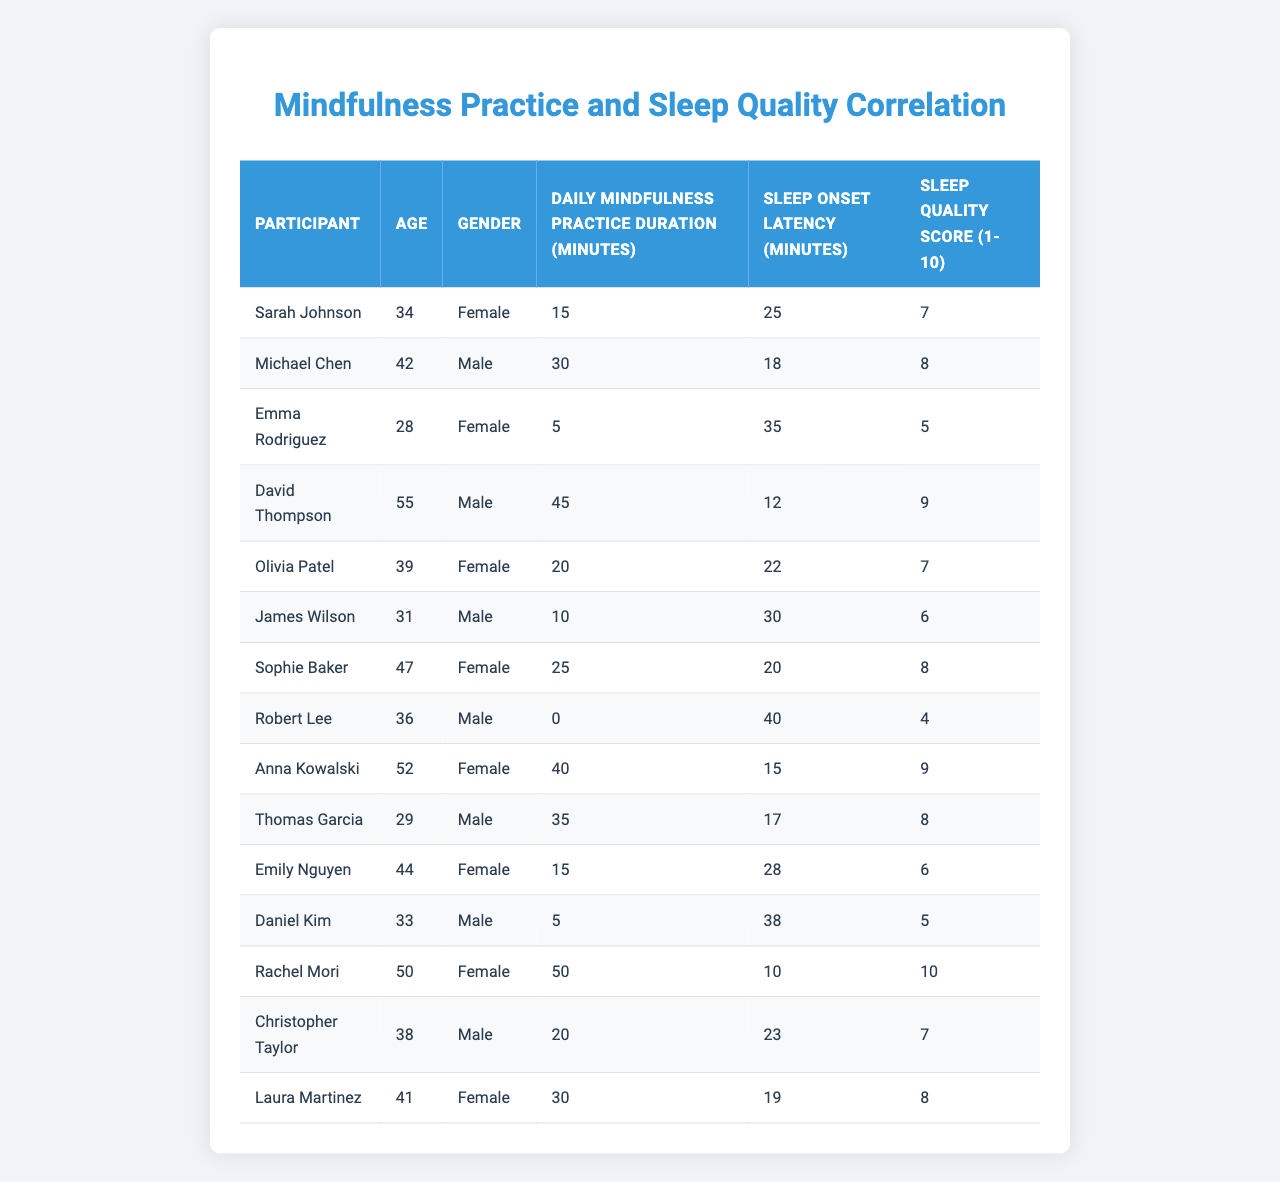What is the sleep onset latency for David Thompson? The table lists David Thompson's sleep onset latency in the respective column, which shows that it is 12 minutes.
Answer: 12 minutes What is the daily mindfulness practice duration for Emma Rodriguez? By checking the corresponding column for Emma Rodriguez, her daily mindfulness practice duration is found to be 5 minutes.
Answer: 5 minutes Which participant has the highest sleep quality score? The sleep quality scores are checked across all participants, and Rachel Mori has the highest score at 10.
Answer: 10 What is the average sleep onset latency for participants who practice mindfulness for 30 minutes or more? First, identify participants with 30 or more minutes of daily mindfulness practice (Michael Chen, David Thompson, Anna Kowalski, Thomas Garcia, Laura Martinez), whose sleep onset latencies are 18, 12, 15, 17, and 19 minutes respectively. Adding these gives 81 minutes, and dividing by 5 gives an average of 16.2 minutes.
Answer: 16.2 minutes Is there a participant who practices mindfulness for 45 minutes or more and also has a sleep quality score of 9 or higher? Looking at the participants, David Thompson practices for 45 minutes with a sleep quality score of 9, satisfying both conditions.
Answer: Yes What is the difference in sleep onset latency between Sarah Johnson and Robert Lee? Sarah Johnson’s sleep onset latency is 25 minutes, while Robert Lee’s is 40 minutes. The difference is calculated as 40 - 25 = 15 minutes.
Answer: 15 minutes How many participants have a sleep quality score of 8 or higher? Counting from the table, the participants with sleep quality scores of 8 or above are Michael Chen, David Thompson, Sophie Baker, Rachel Mori, Thomas Garcia, and Laura Martinez. This totals 6 participants.
Answer: 6 participants What percentage of participants with a daily mindfulness practice of 20 minutes or more have a sleep onset latency of less than 25 minutes? The participants with 20 minutes or more of mindfulness practice are Michael Chen, David Thompson, Olivia Patel, Sophie Baker, Anna Kowalski, Thomas Garcia, and Laura Martinez, totaling 7. Of these, David Thompson (12 minutes), Olivia Patel (22 minutes), and Thomas Garcia (17 minutes) have sleep onset latencies below 25 minutes, totaling 3 participants. Thus, 3 out of 7 participants gives a percentage of (3/7) * 100 ≈ 42.86%.
Answer: 42.86% Who are the participants that have a sleep onset latency greater than 30 minutes? The participants with sleep onset latency greater than 30 minutes are Emma Rodriguez (35 minutes), James Wilson (30 minutes), and Robert Lee (40 minutes).
Answer: Emma Rodriguez, James Wilson, Robert Lee What is the median age of participants who practice mindfulness for less than 15 minutes? Participants practicing less than 15 minutes are Sarah Johnson (34), James Wilson (31), and Robert Lee (36). Ordering their ages gives 31, 34, and 36. The median is the middle value, which is 34 years.
Answer: 34 years 